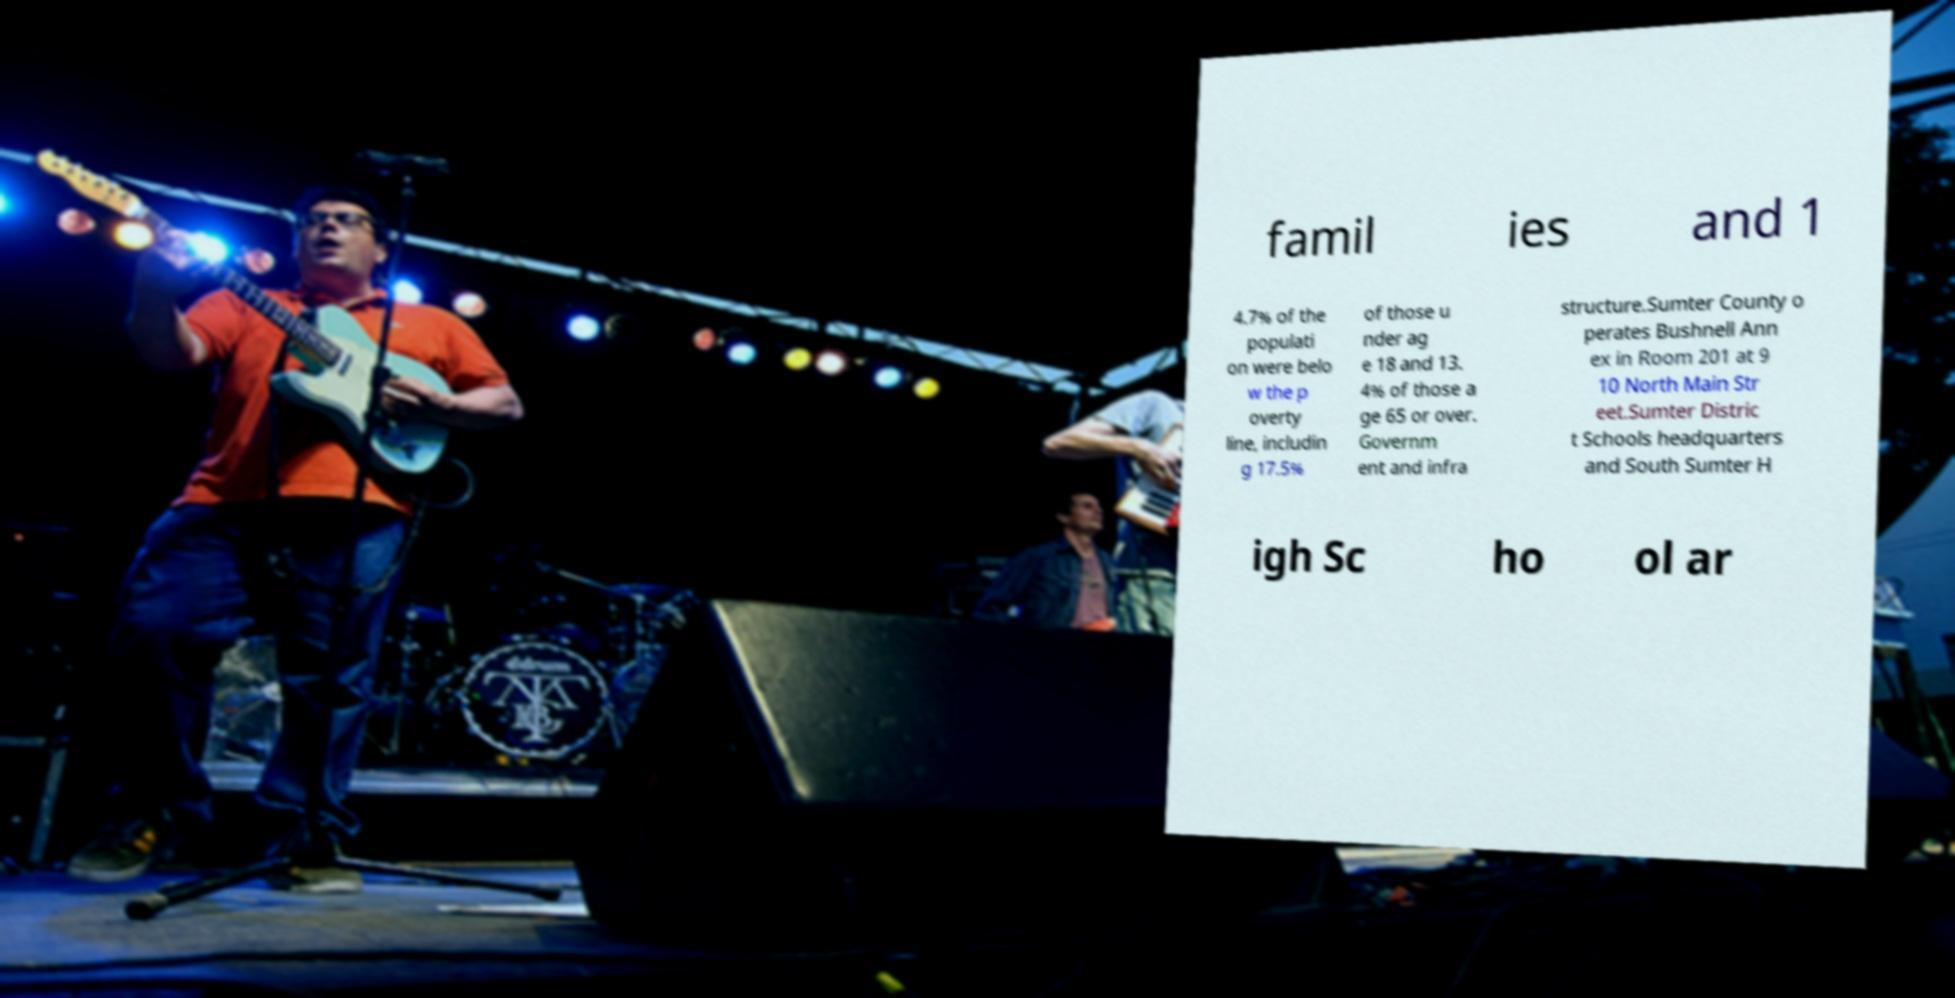I need the written content from this picture converted into text. Can you do that? famil ies and 1 4.7% of the populati on were belo w the p overty line, includin g 17.5% of those u nder ag e 18 and 13. 4% of those a ge 65 or over. Governm ent and infra structure.Sumter County o perates Bushnell Ann ex in Room 201 at 9 10 North Main Str eet.Sumter Distric t Schools headquarters and South Sumter H igh Sc ho ol ar 